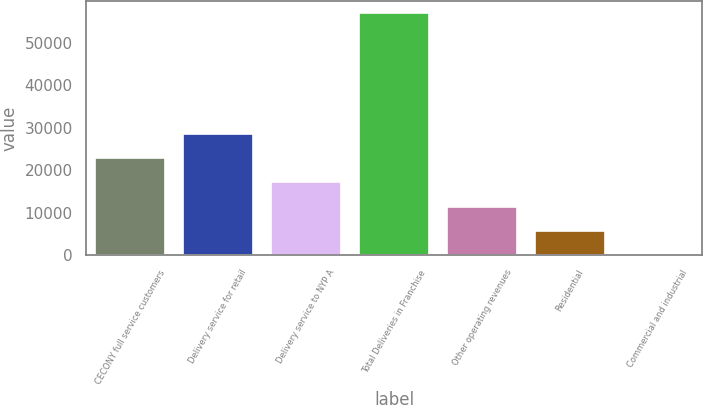Convert chart to OTSL. <chart><loc_0><loc_0><loc_500><loc_500><bar_chart><fcel>CECONY full service customers<fcel>Delivery service for retail<fcel>Delivery service to NYP A<fcel>Total Deliveries in Franchise<fcel>Other operating revenues<fcel>Residential<fcel>Commercial and industrial<nl><fcel>22818.4<fcel>28517.8<fcel>17118.9<fcel>57015<fcel>11419.5<fcel>5720.04<fcel>20.6<nl></chart> 